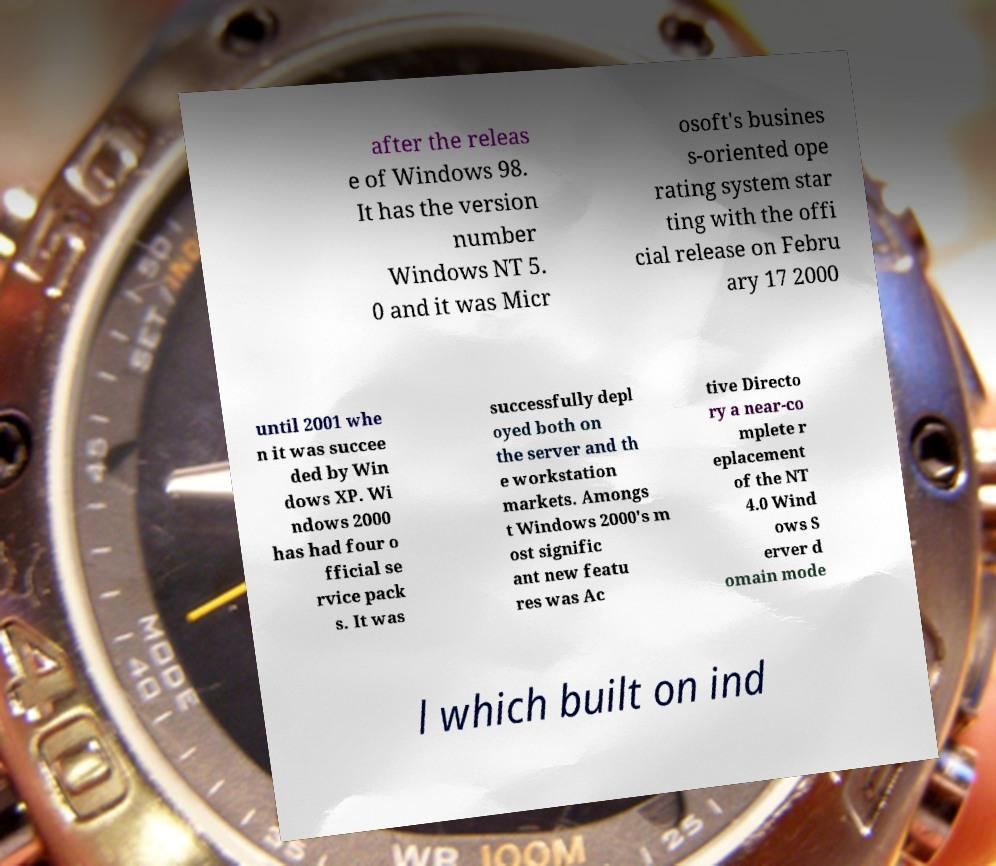What messages or text are displayed in this image? I need them in a readable, typed format. after the releas e of Windows 98. It has the version number Windows NT 5. 0 and it was Micr osoft's busines s-oriented ope rating system star ting with the offi cial release on Febru ary 17 2000 until 2001 whe n it was succee ded by Win dows XP. Wi ndows 2000 has had four o fficial se rvice pack s. It was successfully depl oyed both on the server and th e workstation markets. Amongs t Windows 2000's m ost signific ant new featu res was Ac tive Directo ry a near-co mplete r eplacement of the NT 4.0 Wind ows S erver d omain mode l which built on ind 